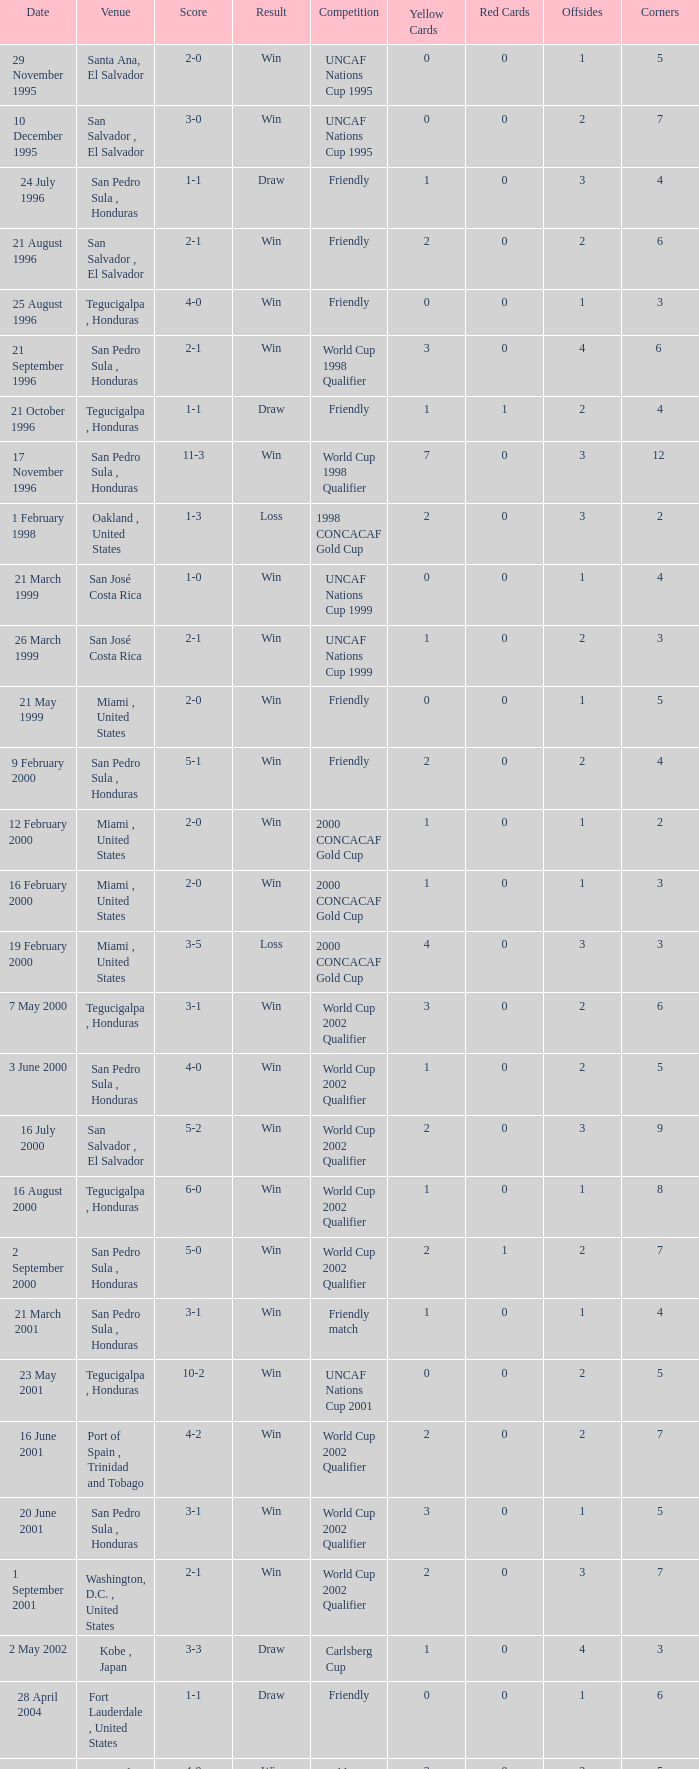Can you give me this table as a dict? {'header': ['Date', 'Venue', 'Score', 'Result', 'Competition', 'Yellow Cards', 'Red Cards', 'Offsides', 'Corners'], 'rows': [['29 November 1995', 'Santa Ana, El Salvador', '2-0', 'Win', 'UNCAF Nations Cup 1995', '0', '0', '1', '5'], ['10 December 1995', 'San Salvador , El Salvador', '3-0', 'Win', 'UNCAF Nations Cup 1995', '0', '0', '2', '7'], ['24 July 1996', 'San Pedro Sula , Honduras', '1-1', 'Draw', 'Friendly', '1', '0', '3', '4'], ['21 August 1996', 'San Salvador , El Salvador', '2-1', 'Win', 'Friendly', '2', '0', '2', '6'], ['25 August 1996', 'Tegucigalpa , Honduras', '4-0', 'Win', 'Friendly', '0', '0', '1', '3'], ['21 September 1996', 'San Pedro Sula , Honduras', '2-1', 'Win', 'World Cup 1998 Qualifier', '3', '0', '4', '6 '], ['21 October 1996', 'Tegucigalpa , Honduras', '1-1', 'Draw', 'Friendly', '1', '1', '2', '4'], ['17 November 1996', 'San Pedro Sula , Honduras', '11-3', 'Win', 'World Cup 1998 Qualifier', '7', '0', '3', '12 '], ['1 February 1998', 'Oakland , United States', '1-3', 'Loss', '1998 CONCACAF Gold Cup', '2', '0', '3', '2'], ['21 March 1999', 'San José Costa Rica', '1-0', 'Win', 'UNCAF Nations Cup 1999', '0', '0', '1', '4'], ['26 March 1999', 'San José Costa Rica', '2-1', 'Win', 'UNCAF Nations Cup 1999', '1', '0', '2', '3'], ['21 May 1999', 'Miami , United States', '2-0', 'Win', 'Friendly', '0', '0', '1', '5'], ['9 February 2000', 'San Pedro Sula , Honduras', '5-1', 'Win', 'Friendly', '2', '0', '2', '4'], ['12 February 2000', 'Miami , United States', '2-0', 'Win', '2000 CONCACAF Gold Cup', '1', '0', '1', '2'], ['16 February 2000', 'Miami , United States', '2-0', 'Win', '2000 CONCACAF Gold Cup', '1', '0', '1', '3'], ['19 February 2000', 'Miami , United States', '3-5', 'Loss', '2000 CONCACAF Gold Cup', '4', '0', '3', '3'], ['7 May 2000', 'Tegucigalpa , Honduras', '3-1', 'Win', 'World Cup 2002 Qualifier', '3', '0', '2', '6'], ['3 June 2000', 'San Pedro Sula , Honduras', '4-0', 'Win', 'World Cup 2002 Qualifier', '1', '0', '2', '5'], ['16 July 2000', 'San Salvador , El Salvador', '5-2', 'Win', 'World Cup 2002 Qualifier', '2', '0', '3', '9'], ['16 August 2000', 'Tegucigalpa , Honduras', '6-0', 'Win', 'World Cup 2002 Qualifier', '1', '0', '1', '8'], ['2 September 2000', 'San Pedro Sula , Honduras', '5-0', 'Win', 'World Cup 2002 Qualifier', '2', '1', '2', '7'], ['21 March 2001', 'San Pedro Sula , Honduras', '3-1', 'Win', 'Friendly match', '1', '0', '1', '4'], ['23 May 2001', 'Tegucigalpa , Honduras', '10-2', 'Win', 'UNCAF Nations Cup 2001', '0', '0', '2', '5'], ['16 June 2001', 'Port of Spain , Trinidad and Tobago', '4-2', 'Win', 'World Cup 2002 Qualifier', '2', '0', '2', '7'], ['20 June 2001', 'San Pedro Sula , Honduras', '3-1', 'Win', 'World Cup 2002 Qualifier', '3', '0', '1', '5'], ['1 September 2001', 'Washington, D.C. , United States', '2-1', 'Win', 'World Cup 2002 Qualifier', '2', '0', '3', '7'], ['2 May 2002', 'Kobe , Japan', '3-3', 'Draw', 'Carlsberg Cup', '1', '0', '4', '3'], ['28 April 2004', 'Fort Lauderdale , United States', '1-1', 'Draw', 'Friendly', '0', '0', '1', '6'], ['19 June 2004', 'San Pedro Sula , Honduras', '4-0', 'Win', 'World Cup 2006 Qualification', '3', '0', '2', '5'], ['19 April 2007', 'La Ceiba , Honduras', '1-3', 'Loss', 'Friendly', '2', '0', '2', '5'], ['25 May 2007', 'Mérida , Venezuela', '1-2', 'Loss', 'Friendly', '2', '0', '2', '4'], ['13 June 2007', 'Houston , United States', '5-0', 'Win', '2007 CONCACAF Gold Cup', '0', '0', '1', '6'], ['17 June 2007', 'Houston , United States', '1-2', 'Loss', '2007 CONCACAF Gold Cup', '1', '0', '3', '4'], ['18 January 2009', 'Miami , United States', '2-0', 'Win', 'Friendly', '0', '0', '0', '3'], ['26 January 2009', 'Tegucigalpa , Honduras', '2-0', 'Win', 'UNCAF Nations Cup 2009', '1', '0', '1', '6'], ['28 March 2009', 'Port of Spain , Trinidad and Tobago', '1-1', 'Draw', 'World Cup 2010 Qualification', '0', '0', '2', '4'], ['1 April 2009', 'San Pedro Sula , Honduras', '3-1', 'Win', 'World Cup 2010 Qualification', '2', '0', '1', '5'], ['10 June 2009', 'San Pedro Sula , Honduras', '1-0', 'Win', 'World Cup 2010 Qualification', '1', '0', '3', '7'], ['12 August 2009', 'San Pedro Sula , Honduras', '4-0', 'Win', 'World Cup 2010 Qualification', '0', '0', '1', '9'], ['5 September 2009', 'San Pedro Sula , Honduras', '4-1', 'Win', 'World Cup 2010 Qualification', '1', '0', '1', '6'], ['14 October 2009', 'San Salvador , El Salvador', '1-0', 'Win', 'World Cup 2010 Qualification', '2', '0', '2', '5'], ['23 January 2010', 'Carson , United States', '3-1', 'Win', 'Friendly', '1', '0', '1', '4']]} Name the date of the uncaf nations cup 2009 26 January 2009. 